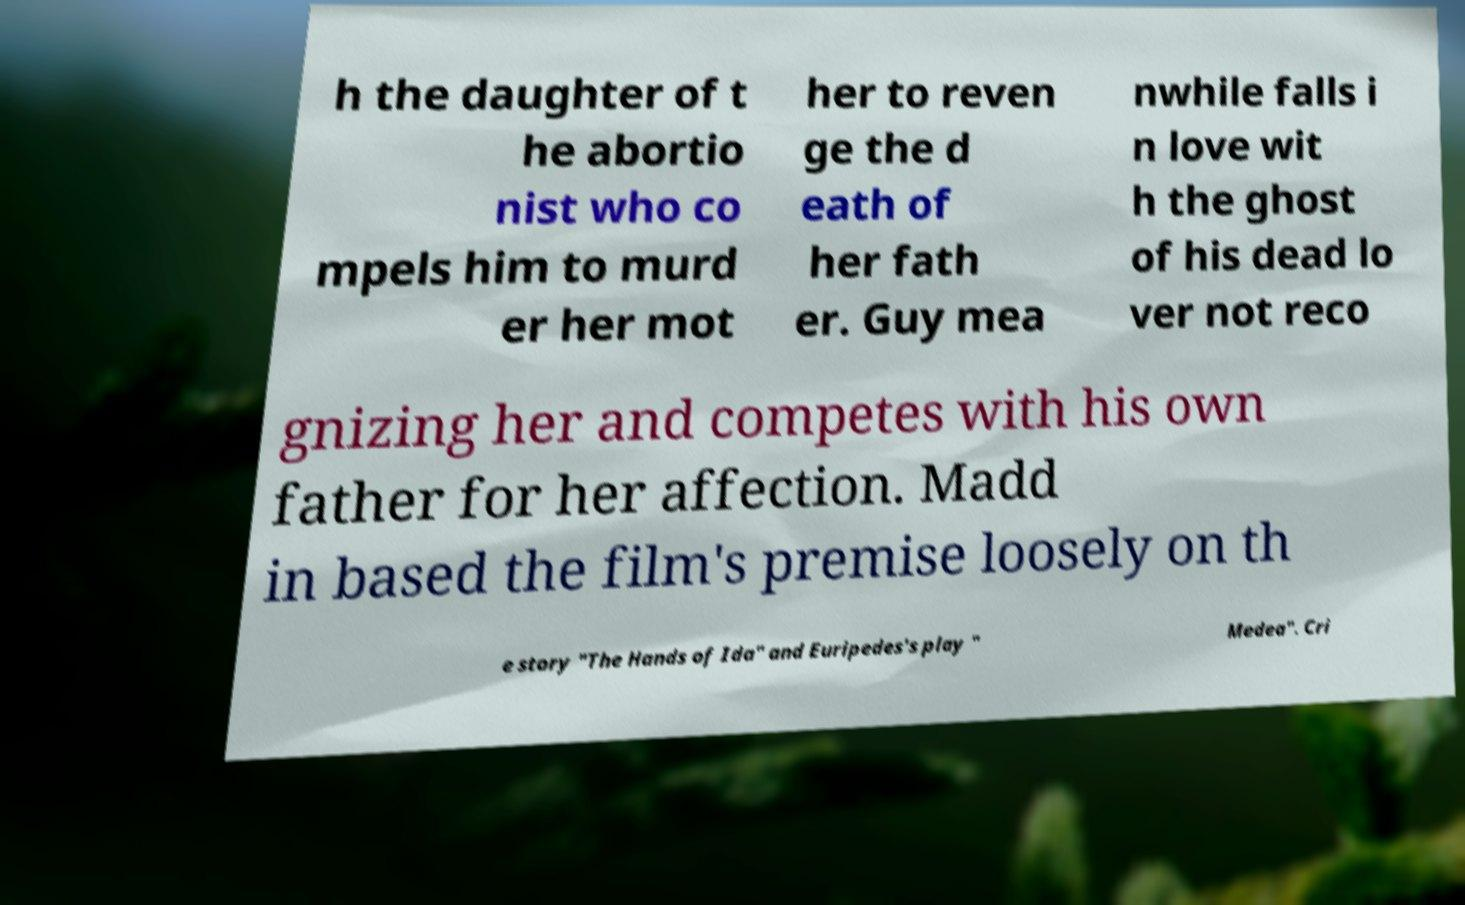Please read and relay the text visible in this image. What does it say? h the daughter of t he abortio nist who co mpels him to murd er her mot her to reven ge the d eath of her fath er. Guy mea nwhile falls i n love wit h the ghost of his dead lo ver not reco gnizing her and competes with his own father for her affection. Madd in based the film's premise loosely on th e story "The Hands of Ida" and Euripedes's play " Medea". Cri 